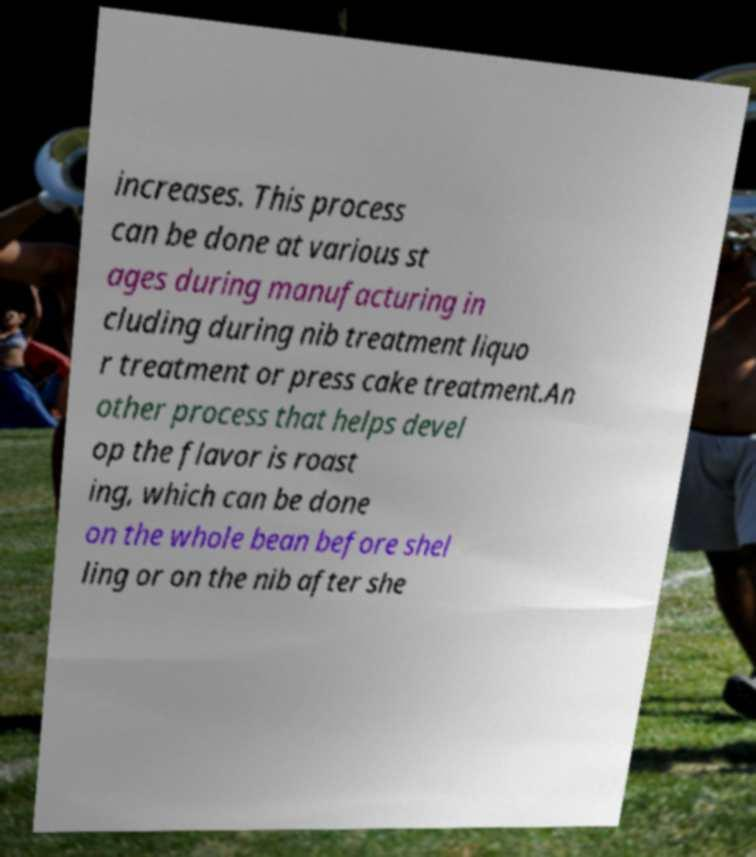Can you read and provide the text displayed in the image?This photo seems to have some interesting text. Can you extract and type it out for me? increases. This process can be done at various st ages during manufacturing in cluding during nib treatment liquo r treatment or press cake treatment.An other process that helps devel op the flavor is roast ing, which can be done on the whole bean before shel ling or on the nib after she 